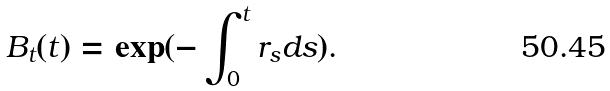<formula> <loc_0><loc_0><loc_500><loc_500>B _ { t } ( t ) = \exp ( - \int _ { 0 } ^ { t } r _ { s } d s ) .</formula> 